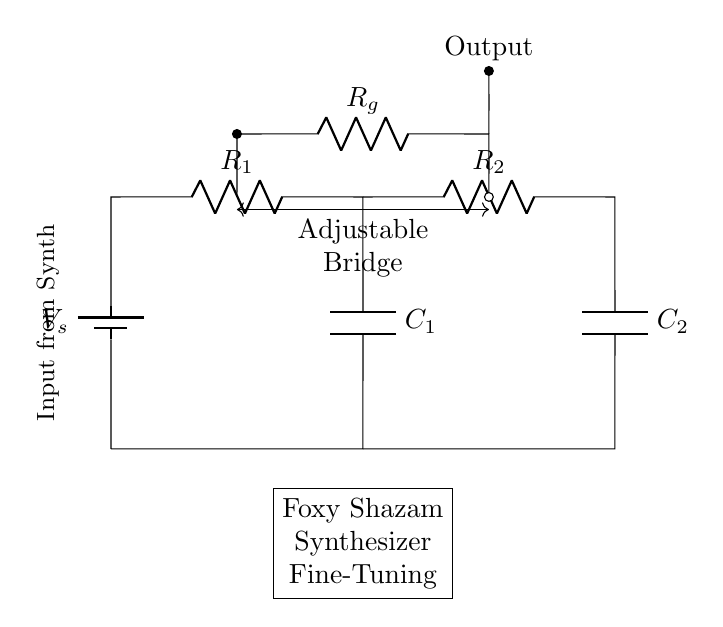What is the source voltage in this circuit? The source voltage is labeled as V_s at the top left of the diagram. It provides the electrical energy for the circuit.
Answer: V_s What types of components are used in this bridge circuit? The circuit includes resistors, capacitors, and a battery as the power source, clearly marked in the diagram.
Answer: Resistors and capacitors How many resistors are present in the circuit? There are three resistors (R_1, R_2, R_g) visible in the circuit, each serving a specific purpose in the bridge design.
Answer: Three What role does R_g play in the circuit? R_g acts as a galvanometer or measuring resistor, indicating whether the bridge is balanced or not; this is inferred from its placement to measure output.
Answer: Measuring resistor How can the bridge be adjusted? The adjustable bridge is indicated by the arrows between R_g and the two capacitors, suggesting variable tuning, achieved by changing the values of R_g or C_1 and C_2.
Answer: By changing resistor or capacitor values Is there an output indicated in the circuit, and where is it? Yes, the output is labeled and located above the R_g resistor, showing where the measurement or signal output can be taken from the bridge circuit.
Answer: Above R_g 